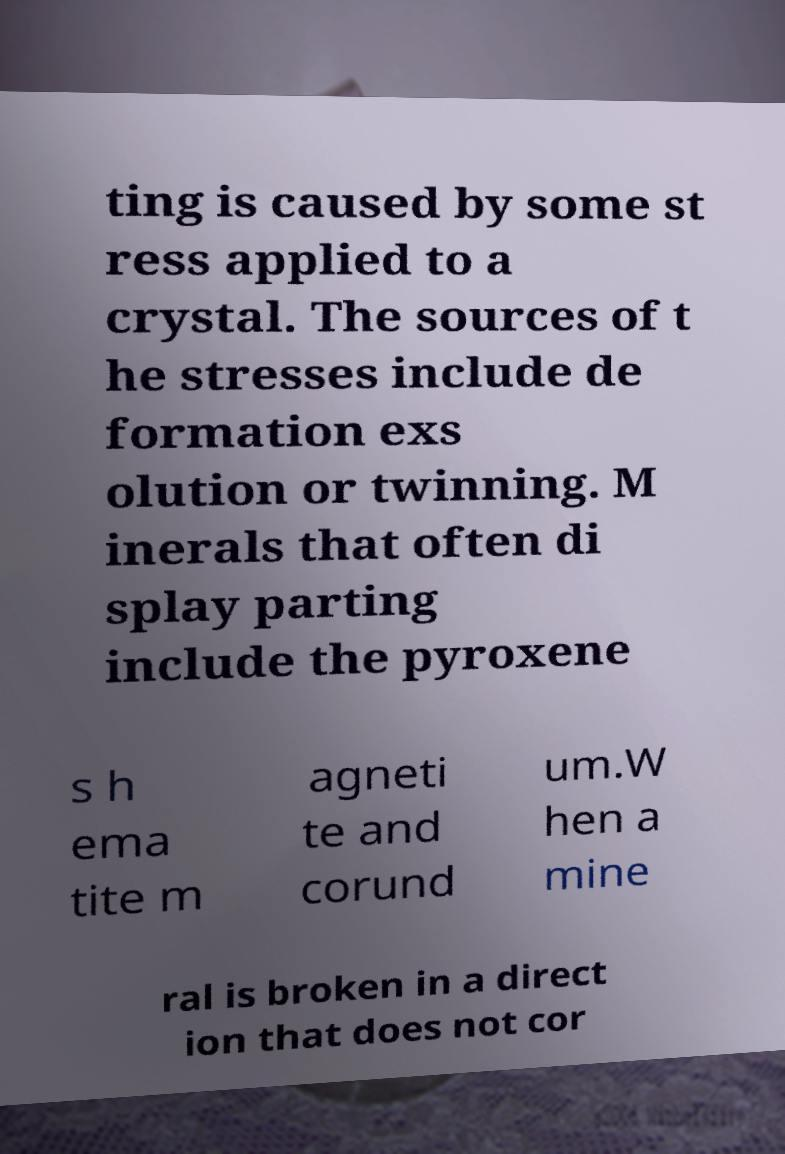Can you accurately transcribe the text from the provided image for me? ting is caused by some st ress applied to a crystal. The sources of t he stresses include de formation exs olution or twinning. M inerals that often di splay parting include the pyroxene s h ema tite m agneti te and corund um.W hen a mine ral is broken in a direct ion that does not cor 